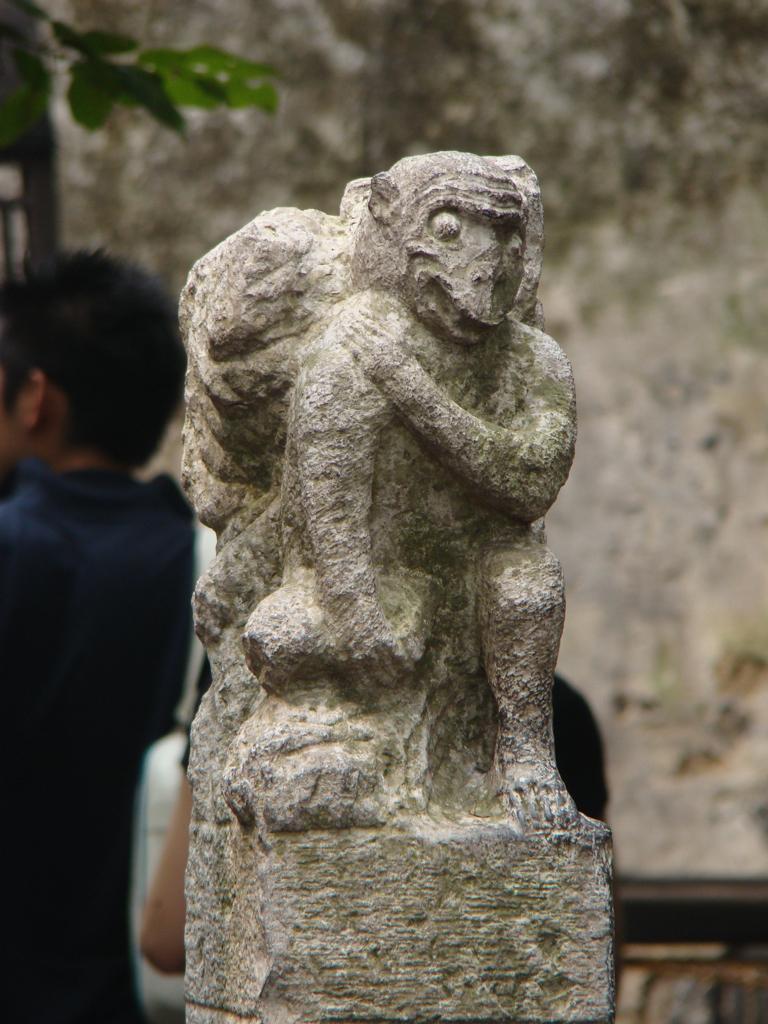Please provide a concise description of this image. In this image we can see a statue. In the background we can see two persons, an object, leaves and wall. 